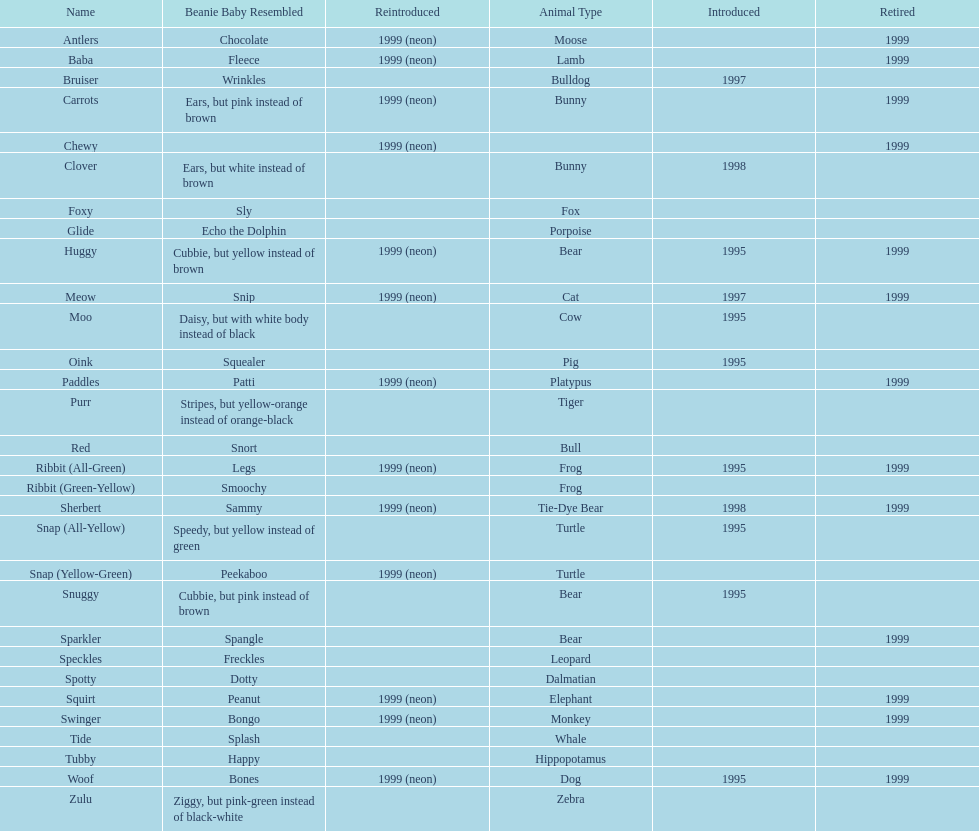How long was woof the dog sold before it was retired? 4 years. 